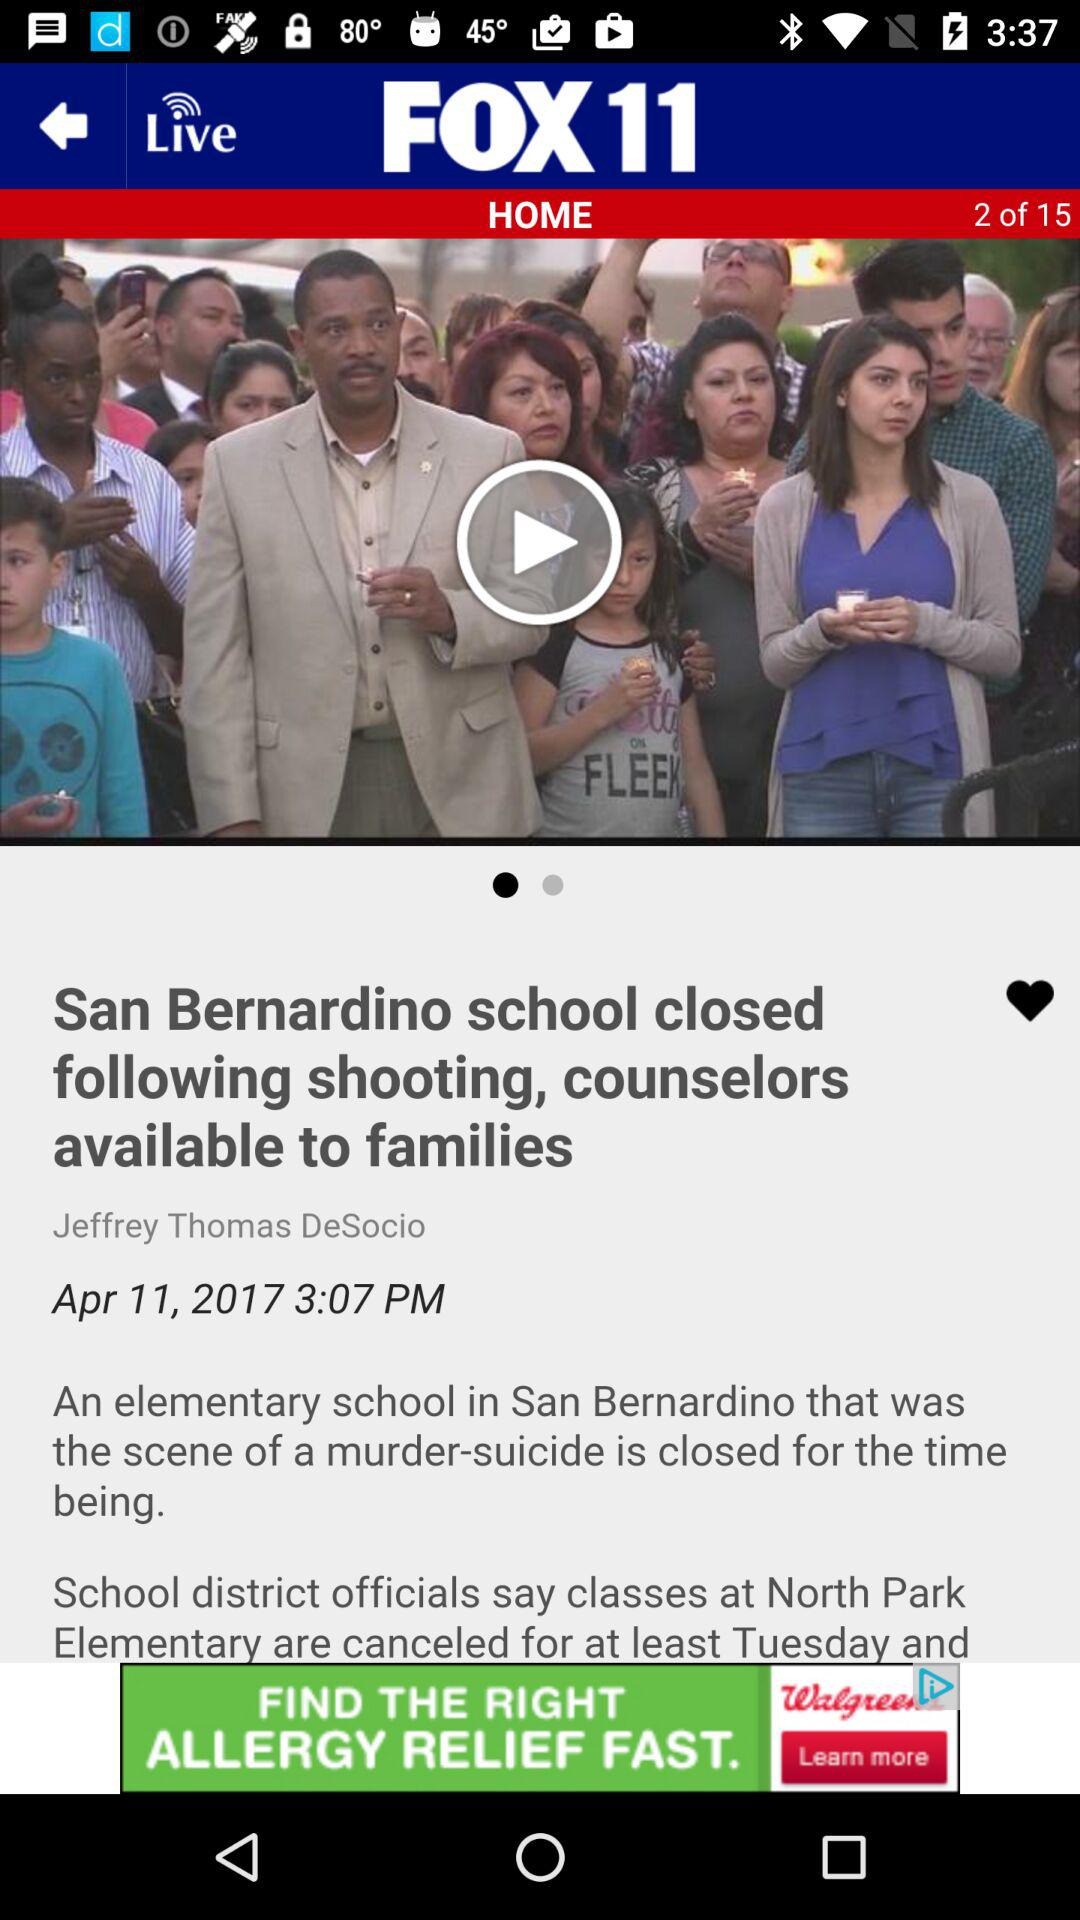What is the headline? The headline is "San Bernardino school closed following shooting, counselors available to families". 